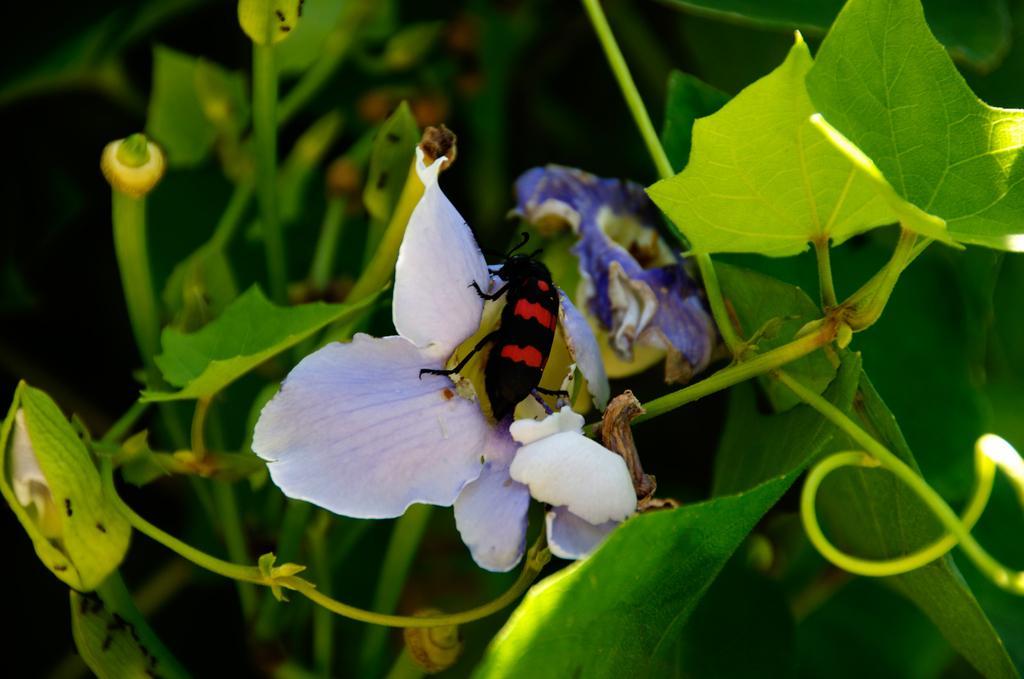How would you summarize this image in a sentence or two? In this picture there is a moth in the center of the image, on the flower and there are plants in the background area of the image. 